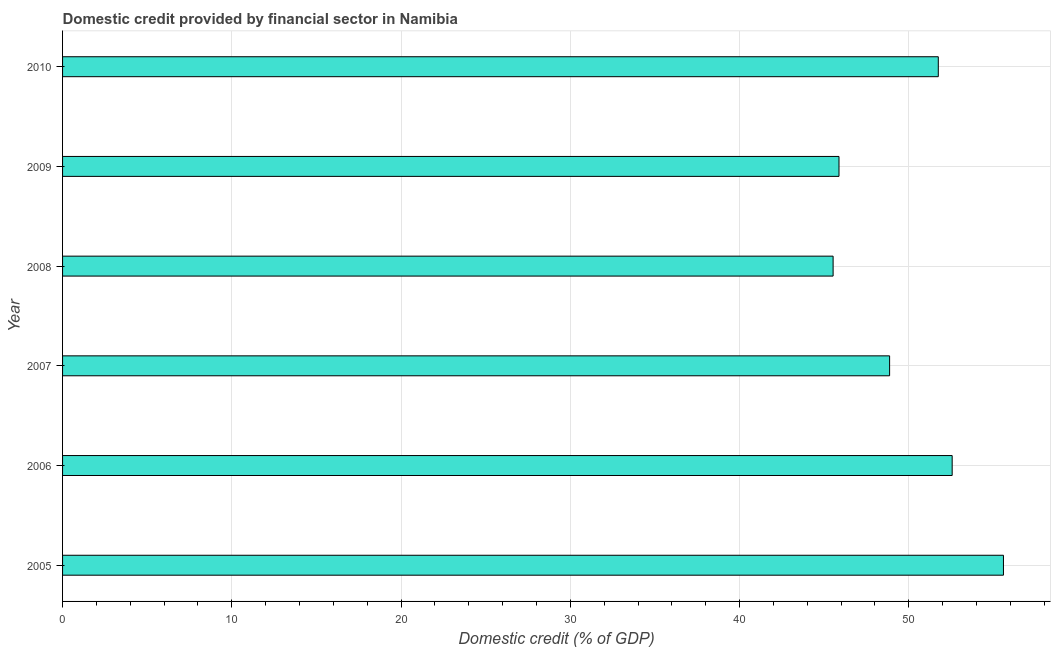Does the graph contain grids?
Keep it short and to the point. Yes. What is the title of the graph?
Provide a short and direct response. Domestic credit provided by financial sector in Namibia. What is the label or title of the X-axis?
Your answer should be compact. Domestic credit (% of GDP). What is the domestic credit provided by financial sector in 2007?
Provide a succinct answer. 48.86. Across all years, what is the maximum domestic credit provided by financial sector?
Offer a very short reply. 55.59. Across all years, what is the minimum domestic credit provided by financial sector?
Offer a terse response. 45.53. In which year was the domestic credit provided by financial sector minimum?
Offer a very short reply. 2008. What is the sum of the domestic credit provided by financial sector?
Make the answer very short. 300.16. What is the difference between the domestic credit provided by financial sector in 2008 and 2010?
Give a very brief answer. -6.21. What is the average domestic credit provided by financial sector per year?
Offer a very short reply. 50.03. What is the median domestic credit provided by financial sector?
Provide a short and direct response. 50.3. What is the ratio of the domestic credit provided by financial sector in 2006 to that in 2009?
Your answer should be very brief. 1.15. Is the difference between the domestic credit provided by financial sector in 2008 and 2010 greater than the difference between any two years?
Your answer should be very brief. No. What is the difference between the highest and the second highest domestic credit provided by financial sector?
Your response must be concise. 3.03. What is the difference between the highest and the lowest domestic credit provided by financial sector?
Offer a very short reply. 10.06. In how many years, is the domestic credit provided by financial sector greater than the average domestic credit provided by financial sector taken over all years?
Keep it short and to the point. 3. How many bars are there?
Your answer should be compact. 6. Are all the bars in the graph horizontal?
Your answer should be very brief. Yes. What is the difference between two consecutive major ticks on the X-axis?
Your response must be concise. 10. What is the Domestic credit (% of GDP) in 2005?
Offer a terse response. 55.59. What is the Domestic credit (% of GDP) of 2006?
Your response must be concise. 52.56. What is the Domestic credit (% of GDP) of 2007?
Your response must be concise. 48.86. What is the Domestic credit (% of GDP) of 2008?
Keep it short and to the point. 45.53. What is the Domestic credit (% of GDP) in 2009?
Offer a terse response. 45.87. What is the Domestic credit (% of GDP) of 2010?
Offer a terse response. 51.74. What is the difference between the Domestic credit (% of GDP) in 2005 and 2006?
Keep it short and to the point. 3.03. What is the difference between the Domestic credit (% of GDP) in 2005 and 2007?
Make the answer very short. 6.73. What is the difference between the Domestic credit (% of GDP) in 2005 and 2008?
Provide a succinct answer. 10.06. What is the difference between the Domestic credit (% of GDP) in 2005 and 2009?
Your answer should be compact. 9.72. What is the difference between the Domestic credit (% of GDP) in 2005 and 2010?
Provide a short and direct response. 3.85. What is the difference between the Domestic credit (% of GDP) in 2006 and 2007?
Your answer should be very brief. 3.7. What is the difference between the Domestic credit (% of GDP) in 2006 and 2008?
Ensure brevity in your answer.  7.03. What is the difference between the Domestic credit (% of GDP) in 2006 and 2009?
Ensure brevity in your answer.  6.69. What is the difference between the Domestic credit (% of GDP) in 2006 and 2010?
Give a very brief answer. 0.82. What is the difference between the Domestic credit (% of GDP) in 2007 and 2008?
Ensure brevity in your answer.  3.34. What is the difference between the Domestic credit (% of GDP) in 2007 and 2009?
Offer a terse response. 2.99. What is the difference between the Domestic credit (% of GDP) in 2007 and 2010?
Provide a succinct answer. -2.88. What is the difference between the Domestic credit (% of GDP) in 2008 and 2009?
Provide a short and direct response. -0.35. What is the difference between the Domestic credit (% of GDP) in 2008 and 2010?
Provide a short and direct response. -6.21. What is the difference between the Domestic credit (% of GDP) in 2009 and 2010?
Your answer should be compact. -5.87. What is the ratio of the Domestic credit (% of GDP) in 2005 to that in 2006?
Your answer should be very brief. 1.06. What is the ratio of the Domestic credit (% of GDP) in 2005 to that in 2007?
Make the answer very short. 1.14. What is the ratio of the Domestic credit (% of GDP) in 2005 to that in 2008?
Keep it short and to the point. 1.22. What is the ratio of the Domestic credit (% of GDP) in 2005 to that in 2009?
Your answer should be very brief. 1.21. What is the ratio of the Domestic credit (% of GDP) in 2005 to that in 2010?
Give a very brief answer. 1.07. What is the ratio of the Domestic credit (% of GDP) in 2006 to that in 2007?
Your response must be concise. 1.08. What is the ratio of the Domestic credit (% of GDP) in 2006 to that in 2008?
Make the answer very short. 1.16. What is the ratio of the Domestic credit (% of GDP) in 2006 to that in 2009?
Make the answer very short. 1.15. What is the ratio of the Domestic credit (% of GDP) in 2007 to that in 2008?
Your answer should be very brief. 1.07. What is the ratio of the Domestic credit (% of GDP) in 2007 to that in 2009?
Your answer should be very brief. 1.06. What is the ratio of the Domestic credit (% of GDP) in 2007 to that in 2010?
Provide a succinct answer. 0.94. What is the ratio of the Domestic credit (% of GDP) in 2008 to that in 2010?
Your answer should be very brief. 0.88. What is the ratio of the Domestic credit (% of GDP) in 2009 to that in 2010?
Make the answer very short. 0.89. 